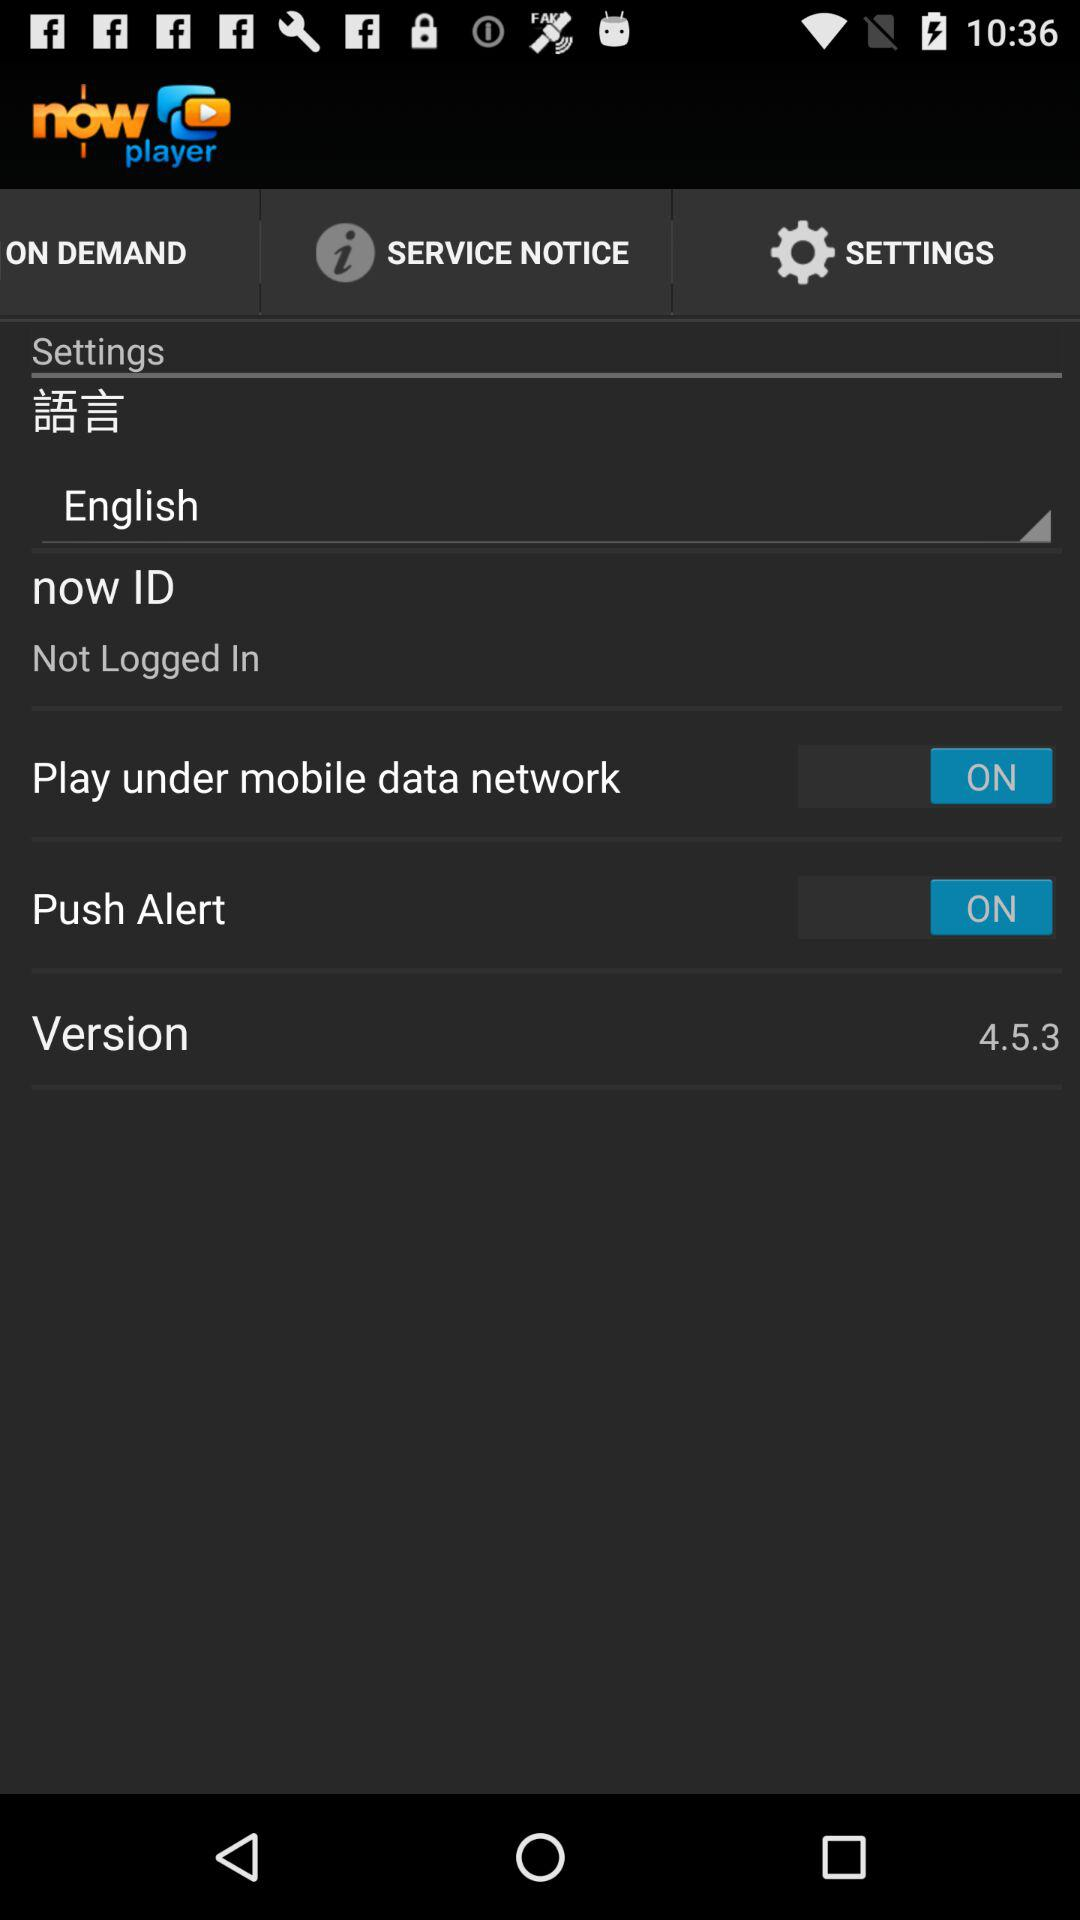What is the version of the app? The version of the app is 4.5.3. 